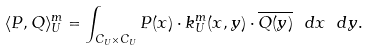<formula> <loc_0><loc_0><loc_500><loc_500>\langle P , Q \rangle ^ { m } _ { U } = \int _ { C _ { U } \times C _ { U } } P ( x ) \cdot k ^ { m } _ { U } ( x , y ) \cdot \overline { Q ( y ) } \ d x \ d y .</formula> 